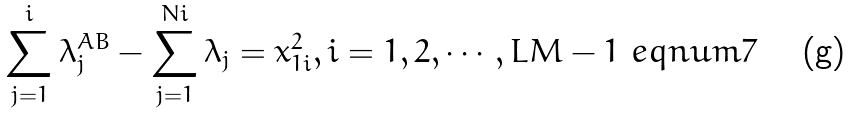<formula> <loc_0><loc_0><loc_500><loc_500>\sum _ { j = 1 } ^ { i } \lambda _ { j } ^ { A B } - \sum _ { j = 1 } ^ { N i } \lambda _ { j } = x _ { 1 i } ^ { 2 } , i = 1 , 2 , \cdots , L M - 1 \ e q n u m { 7 }</formula> 